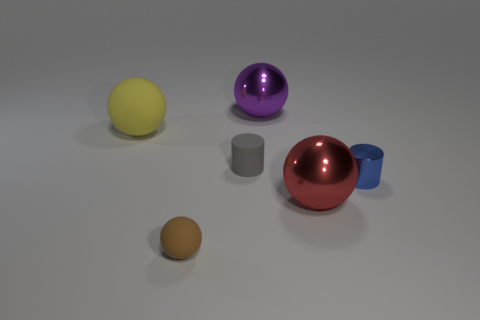Add 3 blue metal cylinders. How many objects exist? 9 Subtract all cylinders. How many objects are left? 4 Subtract all small gray cylinders. Subtract all yellow matte things. How many objects are left? 4 Add 6 big metal balls. How many big metal balls are left? 8 Add 4 small green balls. How many small green balls exist? 4 Subtract 0 cyan blocks. How many objects are left? 6 